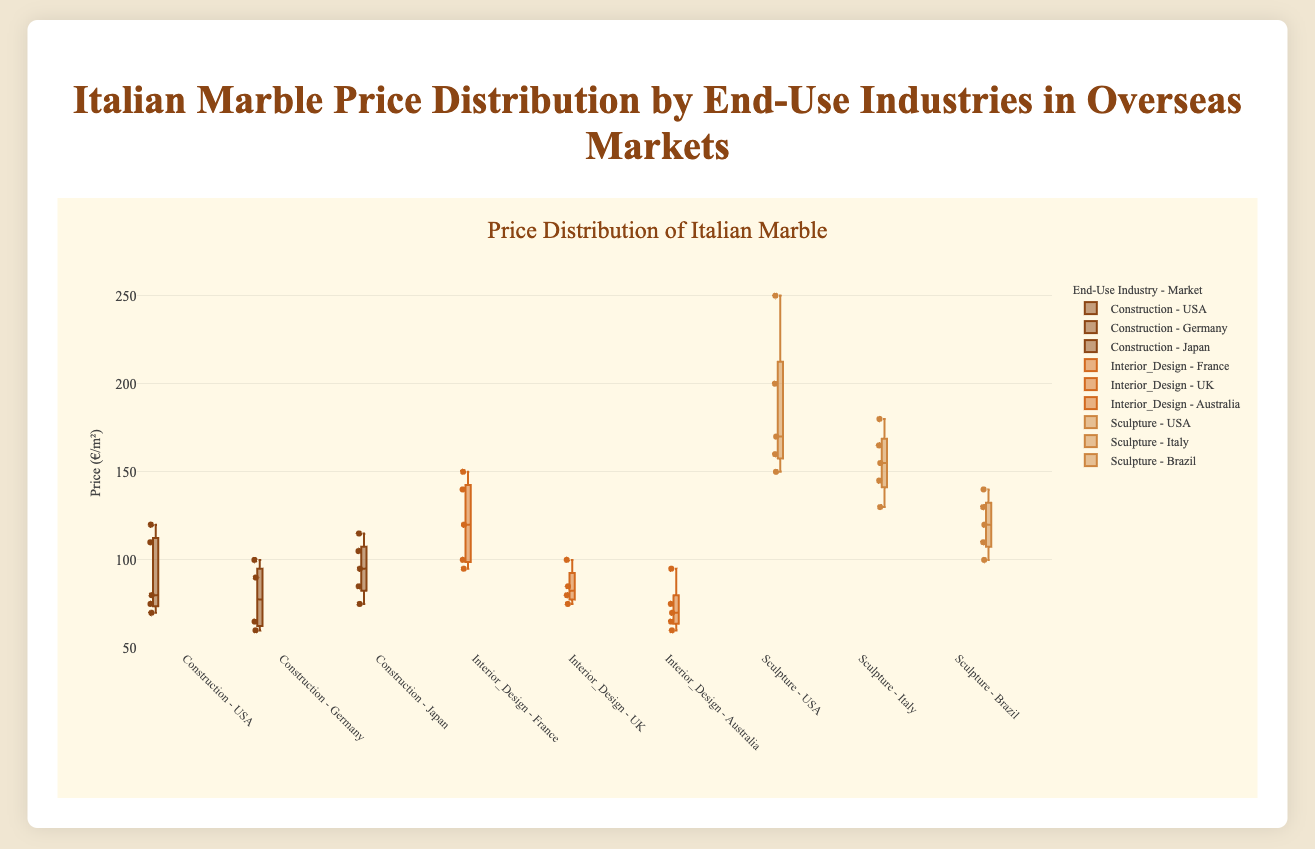What is the title of the figure? The title is displayed on top of the figure and reads "Italian Marble Price Distribution by End-Use Industries in Overseas Markets".
Answer: Italian Marble Price Distribution by End-Use Industries in Overseas Markets Which axis represents the price in the figure? The vertical axis (y-axis) represents the price, as indicated by the label "Price (€/m²)".
Answer: The vertical axis (y-axis) What is the range of prices for Interior Design in the France market? The box plot for Interior Design in the France market shows data points ranging from the minimum to maximum price of around 95 to 150 €/m².
Answer: 95 to 150 €/m² Which end-use industry and market combination shows the highest price? The Sculpture industry in the USA market shows the highest price with a maximum value reaching up to 250 €/m².
Answer: Sculpture in the USA Which market within the Construction industry has the highest median price? By observing the Construction industry box plots, the Japan market has the highest median price at around 95 €/m².
Answer: Japan How does the range of prices in Construction compare between the USA and Germany markets? The USA market shows a price range of 70 to 120 €/m², while the Germany market shows a range of 60 to 100 €/m², indicating that the USA has a wider price range compared to Germany.
Answer: The USA has a wider range What's the median price for the Sculpture industry in the Italy market? The median line in the box plot for Sculpture in the Italy market is around 155 €/m².
Answer: 155 €/m² Which market in the Interior Design industry has the widest interquartile range? The France market in the Interior Design industry shows the widest interquartile range (IQR) with the box's span exceeding other markets.
Answer: France What is the price range for the Sculpture industry in the Brazil market? The box plot for the Sculpture industry in the Brazil market shows a price range from 100 to 140 €/m².
Answer: 100 to 140 €/m² Does the Interior Design industry in the UK market have any outliers, and if so, what are they? The box plot for Interior Design in the UK market shows one outlier above the upper whisker at 100 €/m².
Answer: Yes, 100 €/m² 